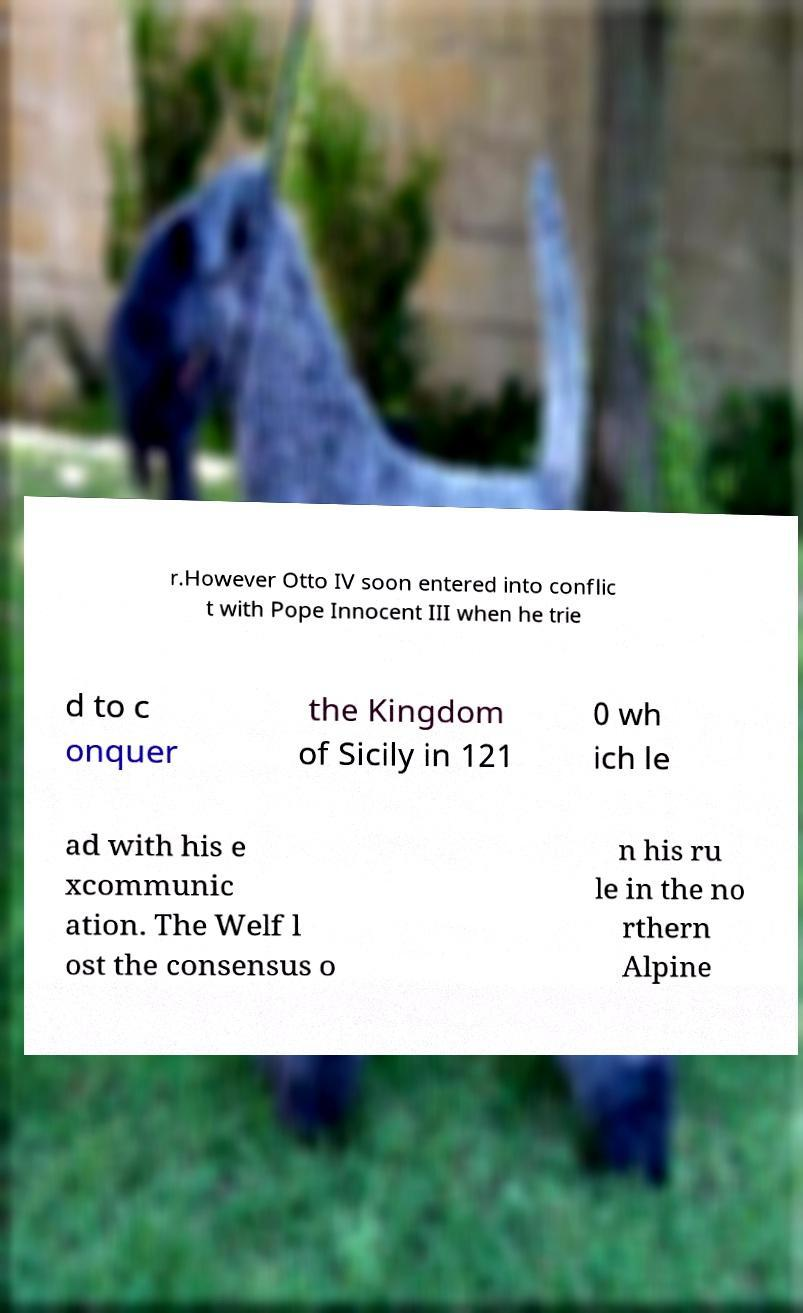Please identify and transcribe the text found in this image. r.However Otto IV soon entered into conflic t with Pope Innocent III when he trie d to c onquer the Kingdom of Sicily in 121 0 wh ich le ad with his e xcommunic ation. The Welf l ost the consensus o n his ru le in the no rthern Alpine 